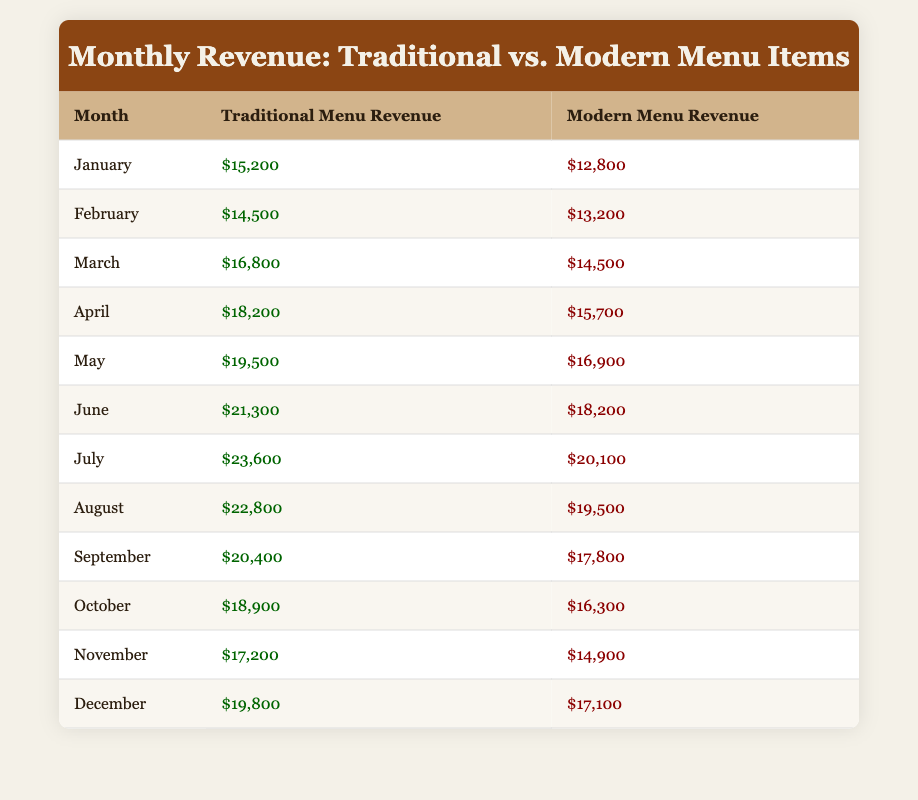What's the total revenue from traditional menu items for December? The table shows the revenue for December under the Traditional Menu Revenue column as $19,800.
Answer: $19,800 In which month did modern menu items generate the highest revenue? By examining the Modern Menu Revenue column, July has the highest revenue at $20,100.
Answer: July What is the total revenue from both menu types in February? In February, the Traditional Menu Revenue is $14,500 and the Modern Menu Revenue is $13,200. Adding these together gives $14,500 + $13,200 = $27,700.
Answer: $27,700 Is the revenue from traditional menu items always higher than that from modern menu items? By checking each month, traditional revenue is higher than modern revenue in every month listed, confirming that this statement is true.
Answer: Yes What is the difference in revenue between traditional and modern menu items for August? The Traditional Menu Revenue for August is $22,800 and Modern Menu Revenue is $19,500. The difference is calculated as $22,800 - $19,500 = $3,300.
Answer: $3,300 What was the average revenue from traditional menu items throughout the year? To find the average, sum all the monthly revenues from the Traditional Menu and divide by 12. The total is $15,200 + $14,500 + $16,800 + $18,200 + $19,500 + $21,300 + $23,600 + $22,800 + $20,400 + $18,900 + $17,200 + $19,800 = $ 224,400, and then divide by 12, which equals $18,700.
Answer: $18,700 In which month did traditional revenue exceed $21,000? By looking at the Traditional Menu Revenue for each month, it is evident that the months where the revenue exceeds $21,000 are June, July, August, and December.
Answer: June, July, August, December Which category started with a higher revenue in January? In January, the Traditional Menu Revenue was $15,200 and the Modern Menu Revenue was $12,800; since $15,200 is greater than $12,800, traditional items started higher.
Answer: Traditional menu items What is the median revenue from modern menu items for the year? The Modern Menu Revenue values in sorted order are $12,800, $13,200, $14,500, $15,700, $16,300, $16,900, $17,800, $18,200, $19,500, $20,100, $17,100, $14,900. The median is the average of the 6th and 7th numbers, which are $16,900 and $17,800; hence (16,900 + 17,800)/2 = $17,350.
Answer: $17,350 